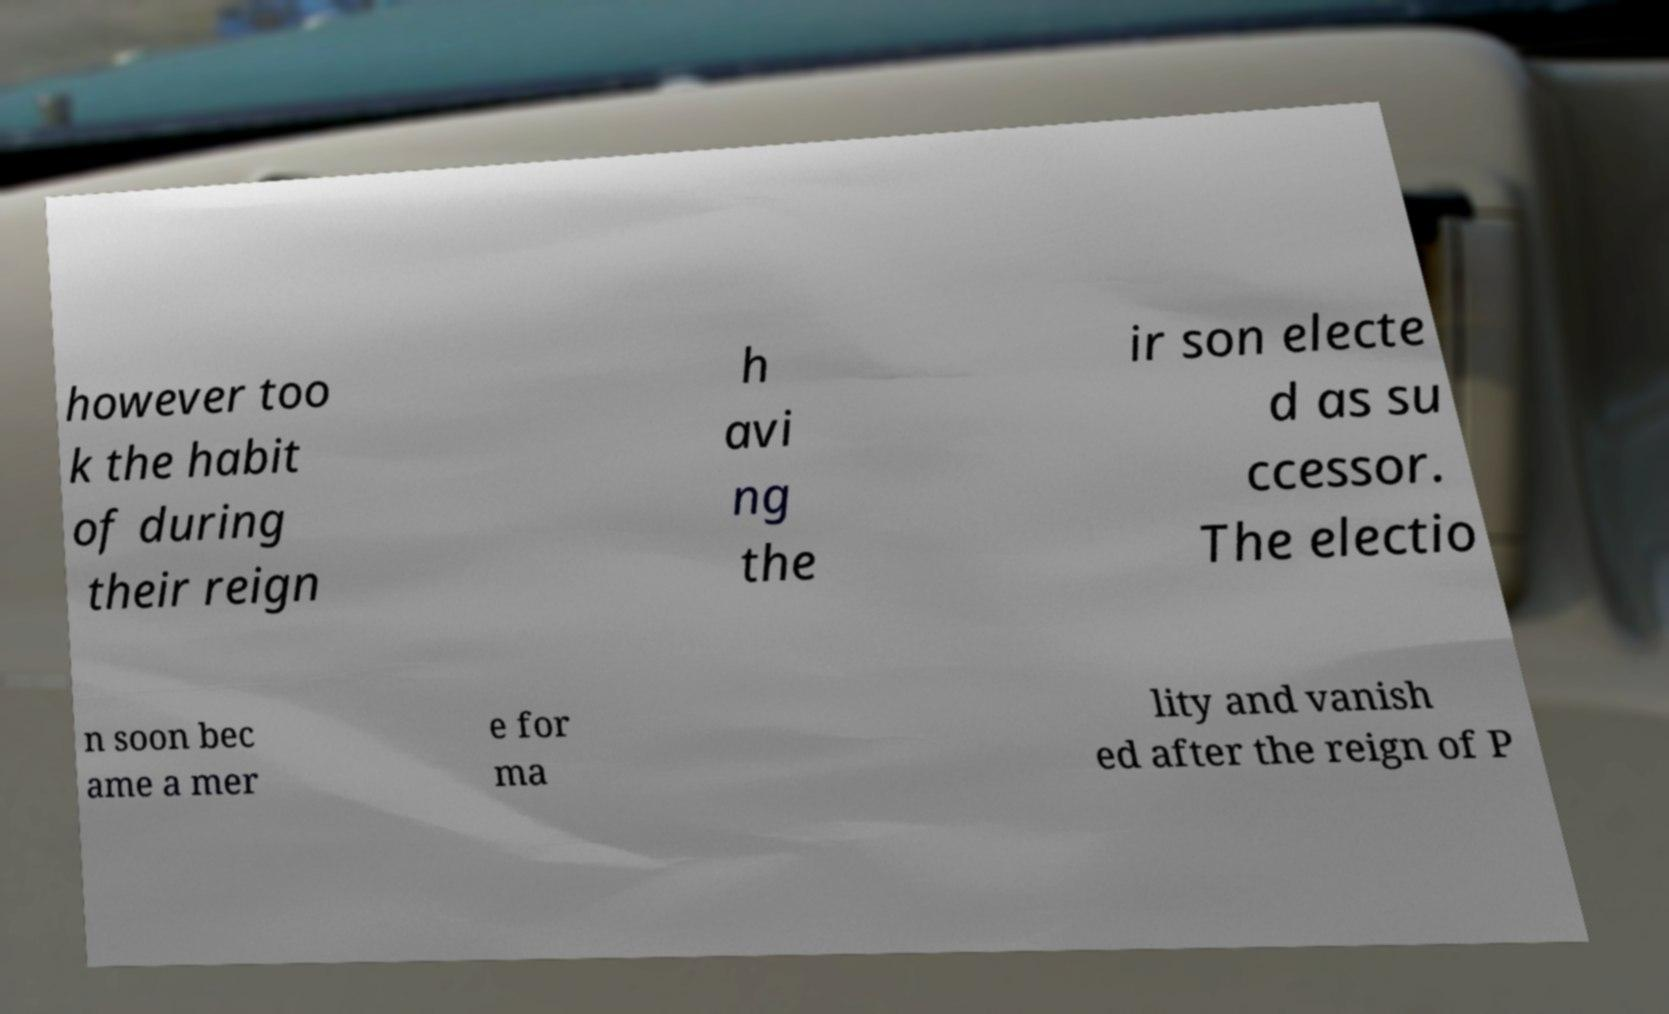For documentation purposes, I need the text within this image transcribed. Could you provide that? however too k the habit of during their reign h avi ng the ir son electe d as su ccessor. The electio n soon bec ame a mer e for ma lity and vanish ed after the reign of P 